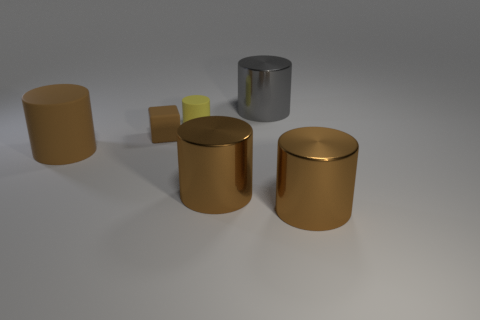Subtract all big gray cylinders. How many cylinders are left? 4 Add 1 big rubber objects. How many objects exist? 7 Subtract all cylinders. How many objects are left? 1 Subtract all gray cylinders. How many cylinders are left? 4 Subtract 0 blue spheres. How many objects are left? 6 Subtract 3 cylinders. How many cylinders are left? 2 Subtract all green cubes. Subtract all blue balls. How many cubes are left? 1 Subtract all brown blocks. How many brown cylinders are left? 3 Subtract all rubber cylinders. Subtract all tiny rubber things. How many objects are left? 2 Add 3 large brown matte cylinders. How many large brown matte cylinders are left? 4 